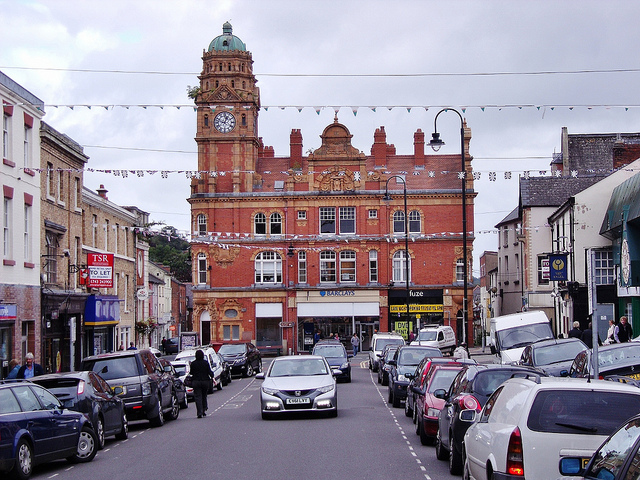Please transcribe the text information in this image. TSR TOLET fuIe 